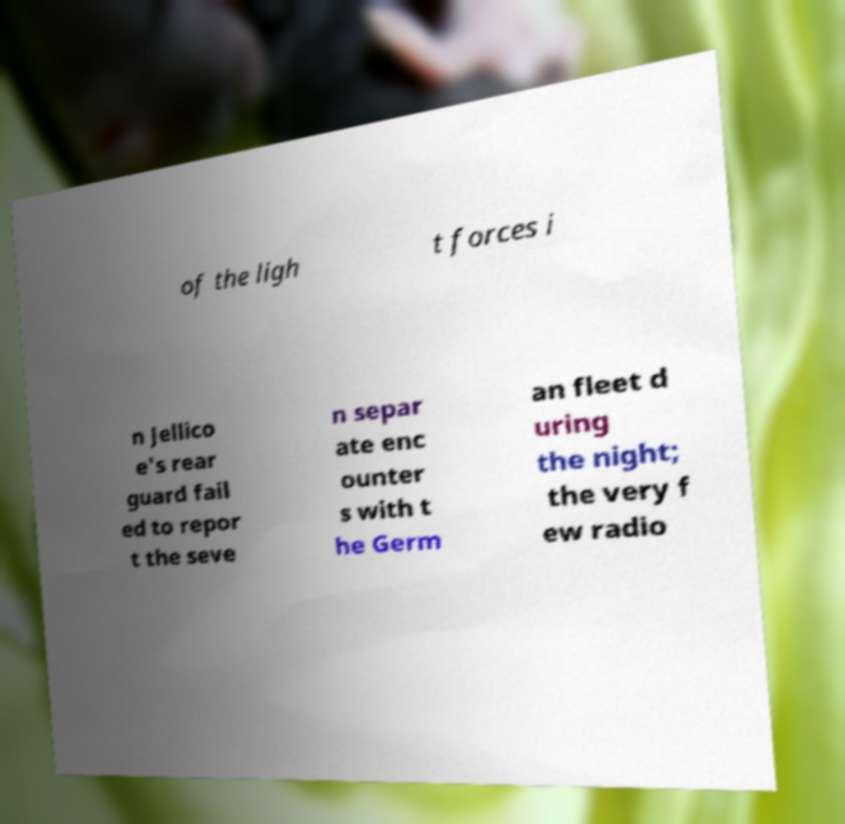I need the written content from this picture converted into text. Can you do that? of the ligh t forces i n Jellico e's rear guard fail ed to repor t the seve n separ ate enc ounter s with t he Germ an fleet d uring the night; the very f ew radio 